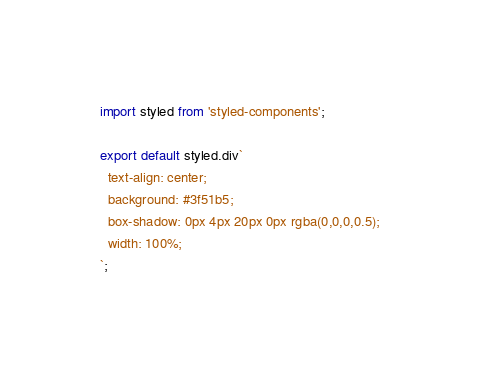<code> <loc_0><loc_0><loc_500><loc_500><_JavaScript_>import styled from 'styled-components';

export default styled.div`
  text-align: center;
  background: #3f51b5;
  box-shadow: 0px 4px 20px 0px rgba(0,0,0,0.5);
  width: 100%;
`;
</code> 